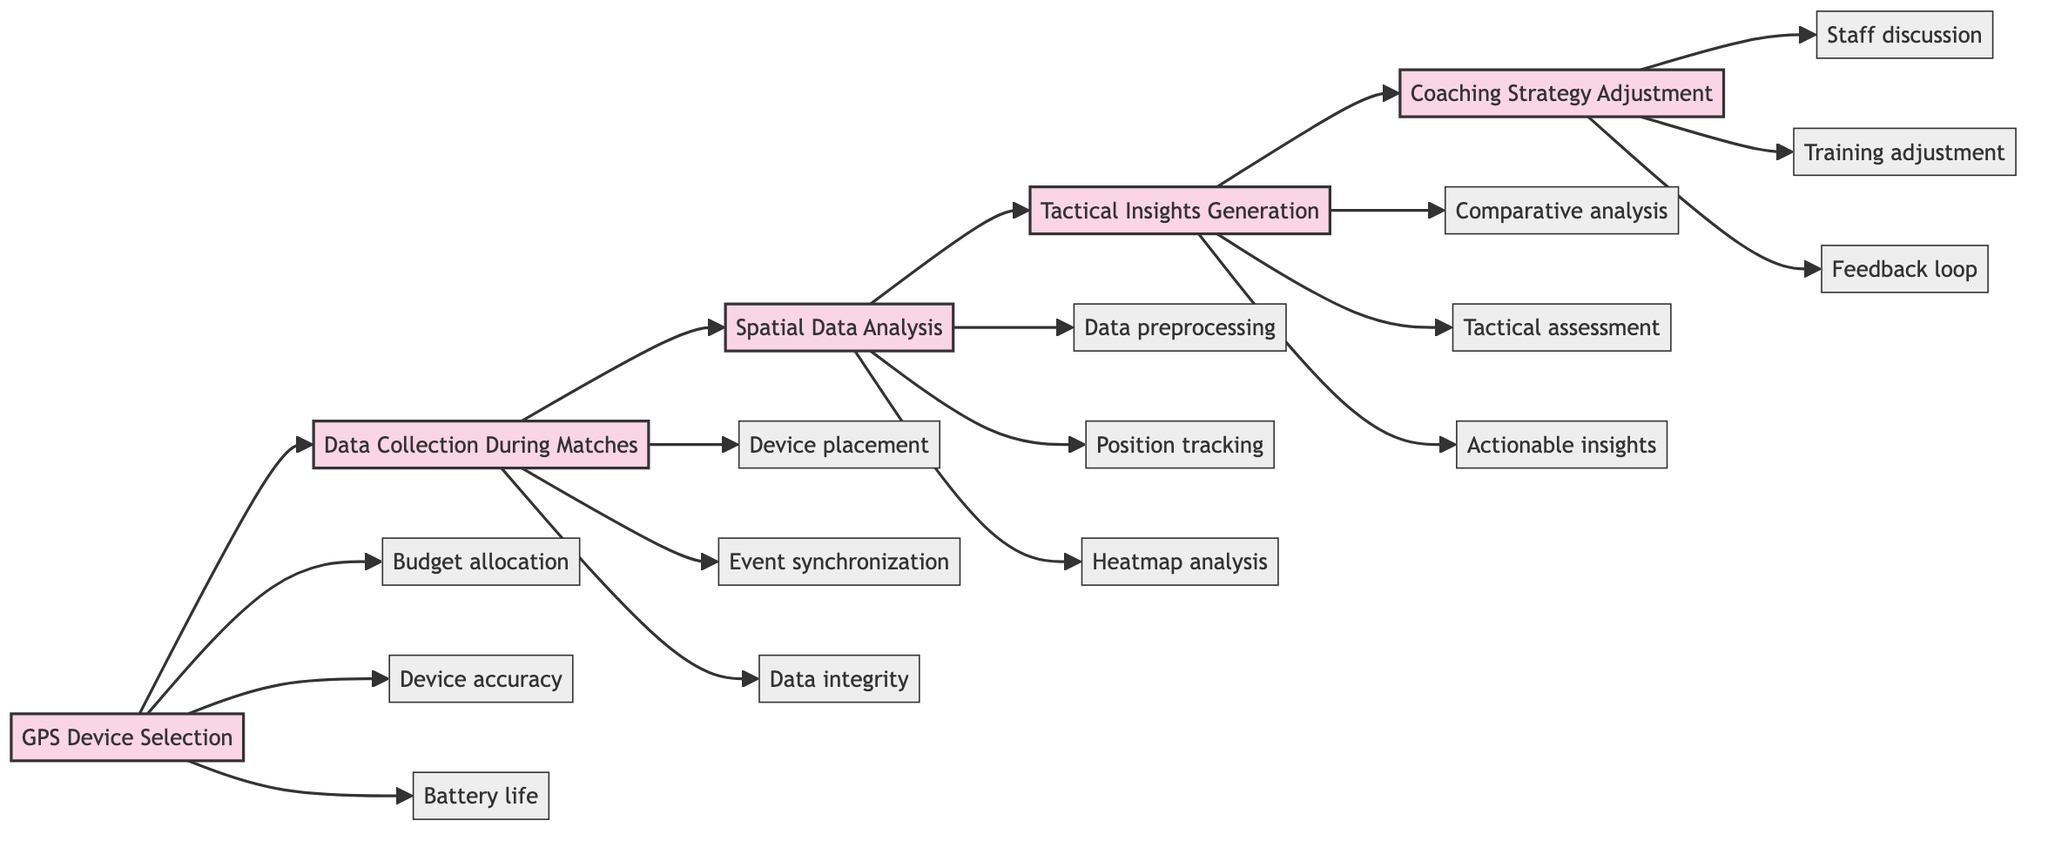What is the first phase in the flowchart? The first phase in the flowchart is identified as "GPS Device Selection," which is represented at the starting point of the diagram.
Answer: GPS Device Selection How many elements are there under "Tactical Insights Generation"? By counting the elements listed under "Tactical Insights Generation," we find there are three: comparative analysis, tactical assessment, and actionable insights.
Answer: 3 What comes after "Data Collection During Matches"? The flowchart indicates that "Spatial Data Analysis" follows directly after "Data Collection During Matches," establishing a sequential relationship.
Answer: Spatial Data Analysis Which phase contains a focus on budget allocation? "GPS Device Selection" is the phase that includes the element focusing on budget allocation, as it is specifically mentioned as one of its elements.
Answer: GPS Device Selection What is the last phase in the flowchart? The last phase in the flowchart is identified as "Coaching Strategy Adjustment," which concludes the sequence of phases depicted in the diagram.
Answer: Coaching Strategy Adjustment Which element is associated with monitoring real-time gameplay? The element associated with monitoring real-time gameplay is "Data integrity," which is specifically mentioned under the "Data Collection During Matches" phase.
Answer: Data integrity What is the relationship between "Spatial Data Analysis" and "Coaching Strategy Adjustment"? "Spatial Data Analysis" contributes to informing the "Coaching Strategy Adjustment," as insights from the analysis will likely lead to adjustments in coaching strategies. This reflects a cause-effect relationship in the flow of information.
Answer: Informing adjustments How many total phases are represented in the diagram? There are five total phases represented in the diagram, as specifically outlined by the different sections of the flowchart.
Answer: 5 Which software might be mentioned for movement density analysis? The software mentioned for movement density analysis is "R or Python," indicated in the "Spatial Data Analysis" phase.
Answer: R or Python 